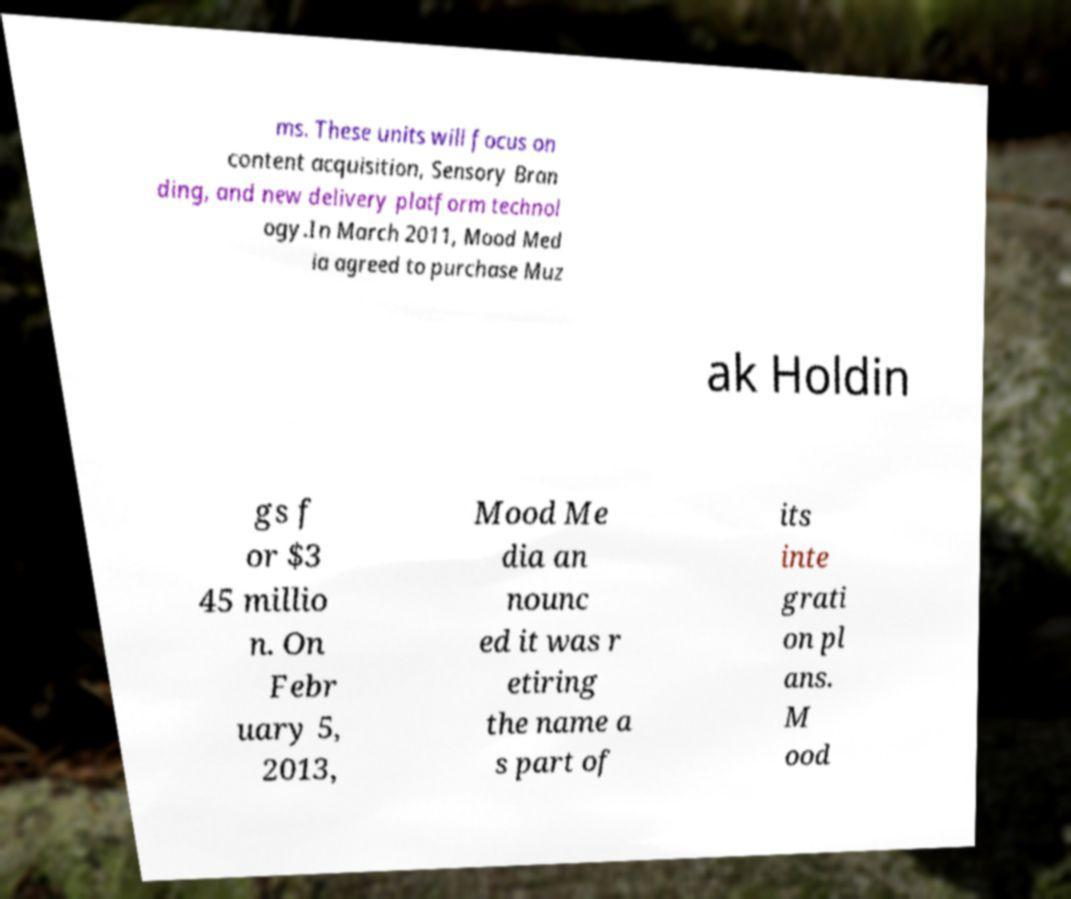For documentation purposes, I need the text within this image transcribed. Could you provide that? ms. These units will focus on content acquisition, Sensory Bran ding, and new delivery platform technol ogy.In March 2011, Mood Med ia agreed to purchase Muz ak Holdin gs f or $3 45 millio n. On Febr uary 5, 2013, Mood Me dia an nounc ed it was r etiring the name a s part of its inte grati on pl ans. M ood 